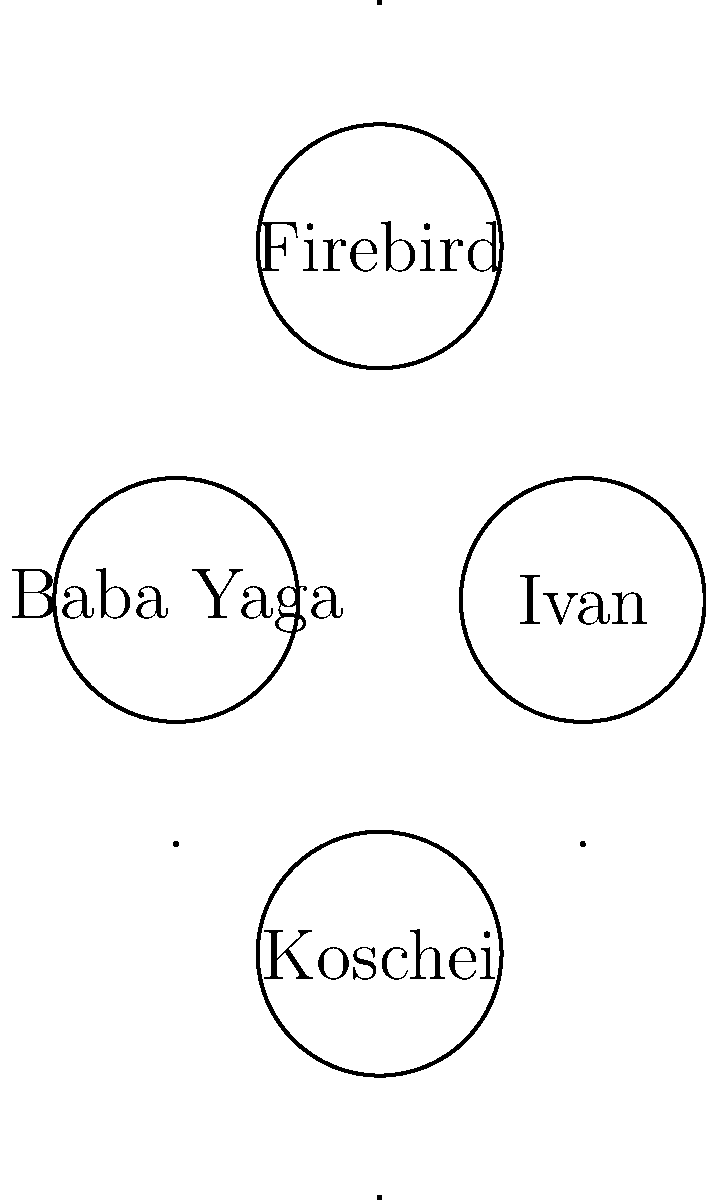Match the following Russian folktale characters to their iconic symbols or attributes:

1. Baba Yaga
2. Ivan
3. Firebird
4. Koschei

A. Triangle
B. Pentagon
C. Circle
D. Square To match the Russian folktale characters to their iconic symbols or attributes, let's consider each character and their associated symbolism:

1. Baba Yaga: In Russian folklore, Baba Yaga is often associated with a mortar and pestle, but more importantly, her house stands on chicken legs. The pentagon (B) represents the unique, multi-faceted nature of her dwelling.

2. Ivan: As the heroic protagonist in many Russian fairy tales, Ivan is often depicted as a simple, straightforward character. The triangle (A) symbolizes his journey and growth throughout the story, with each side representing a challenge he must overcome.

3. Firebird: This magical glowing bird is a central character in many Russian folktales. Its radiant feathers are said to light up a room even in complete darkness. The circle (C) represents the Firebird's brilliant, glowing nature and its association with the sun.

4. Koschei: Known as Koschei the Deathless, this character is often portrayed as an evil sorcerer or overlord. The square (D) symbolizes his rigid, unyielding nature and the boundaries of his power.

By matching these symbolic representations to the characters, we can connect each folktale figure to their iconic attribute.
Answer: 1-B, 2-A, 3-C, 4-D 